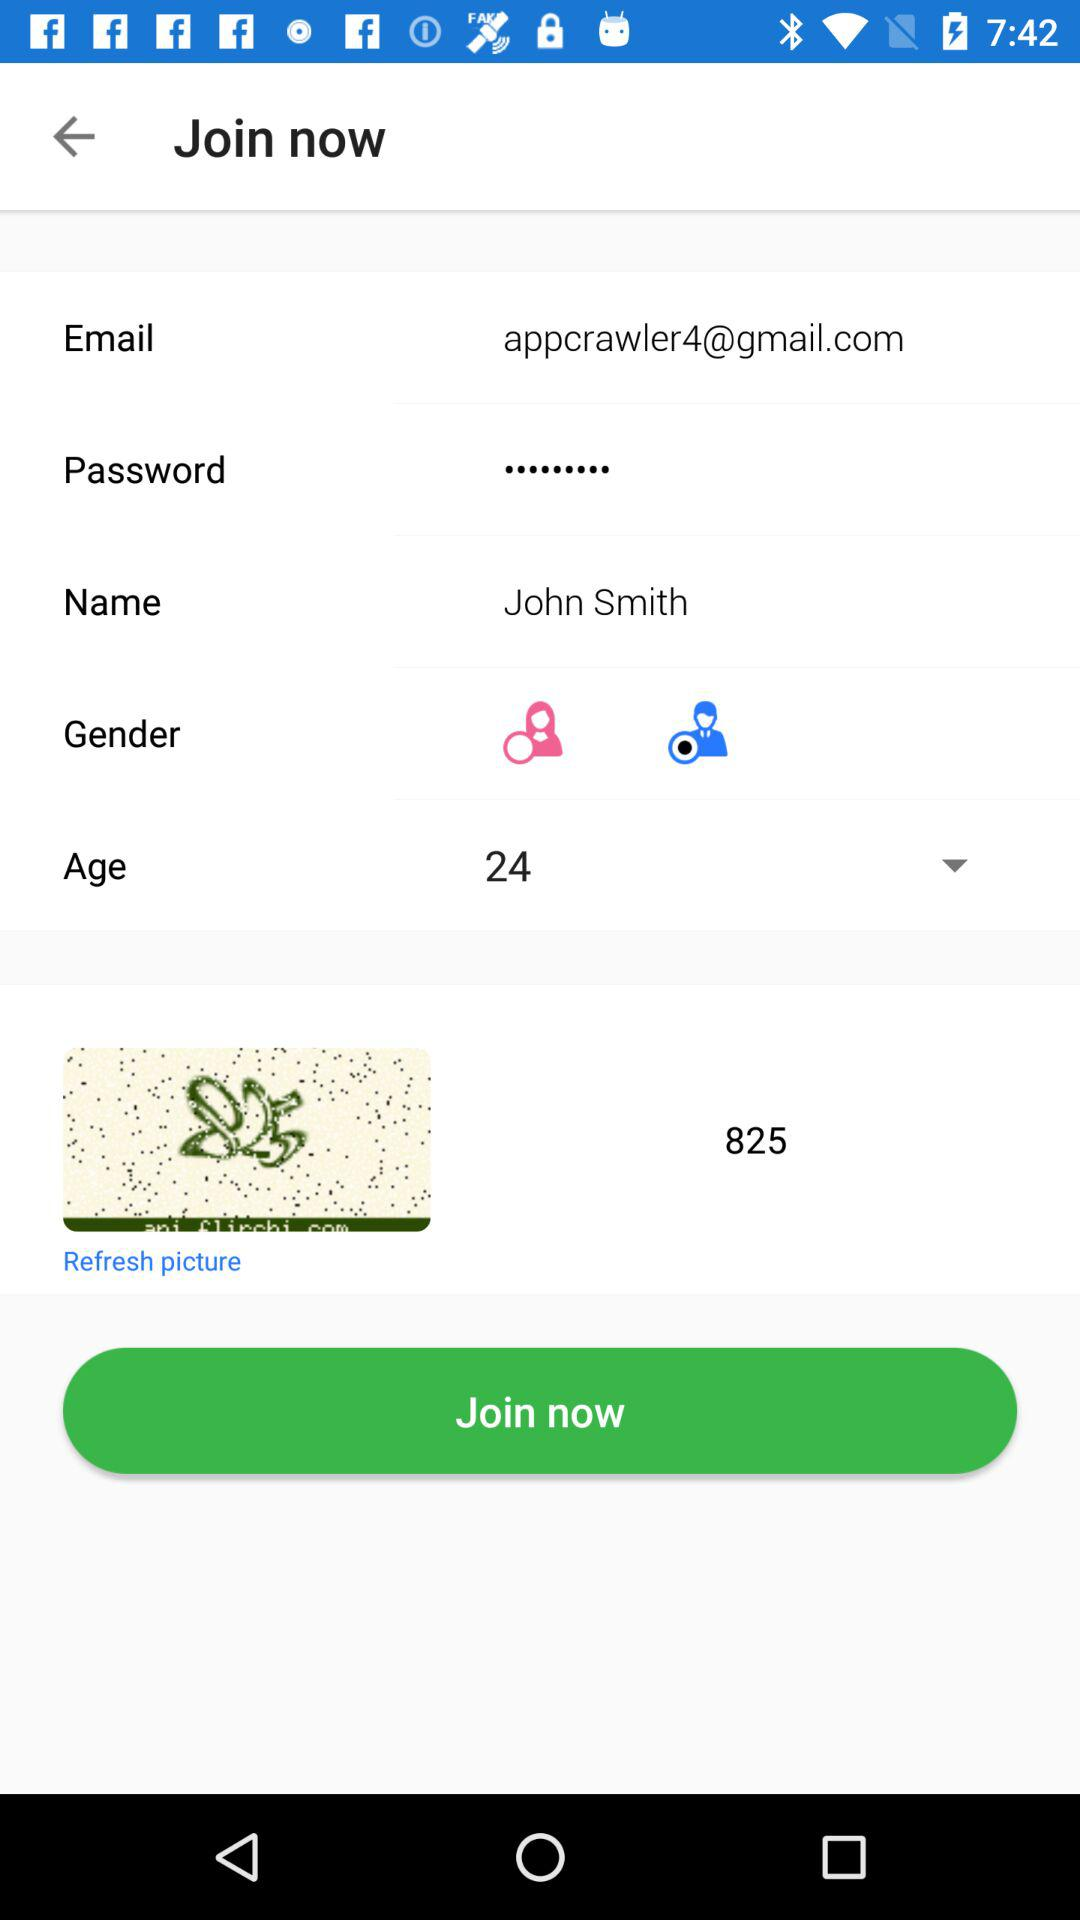What is the email address? The email address is appcrawler4@gmail.com. 